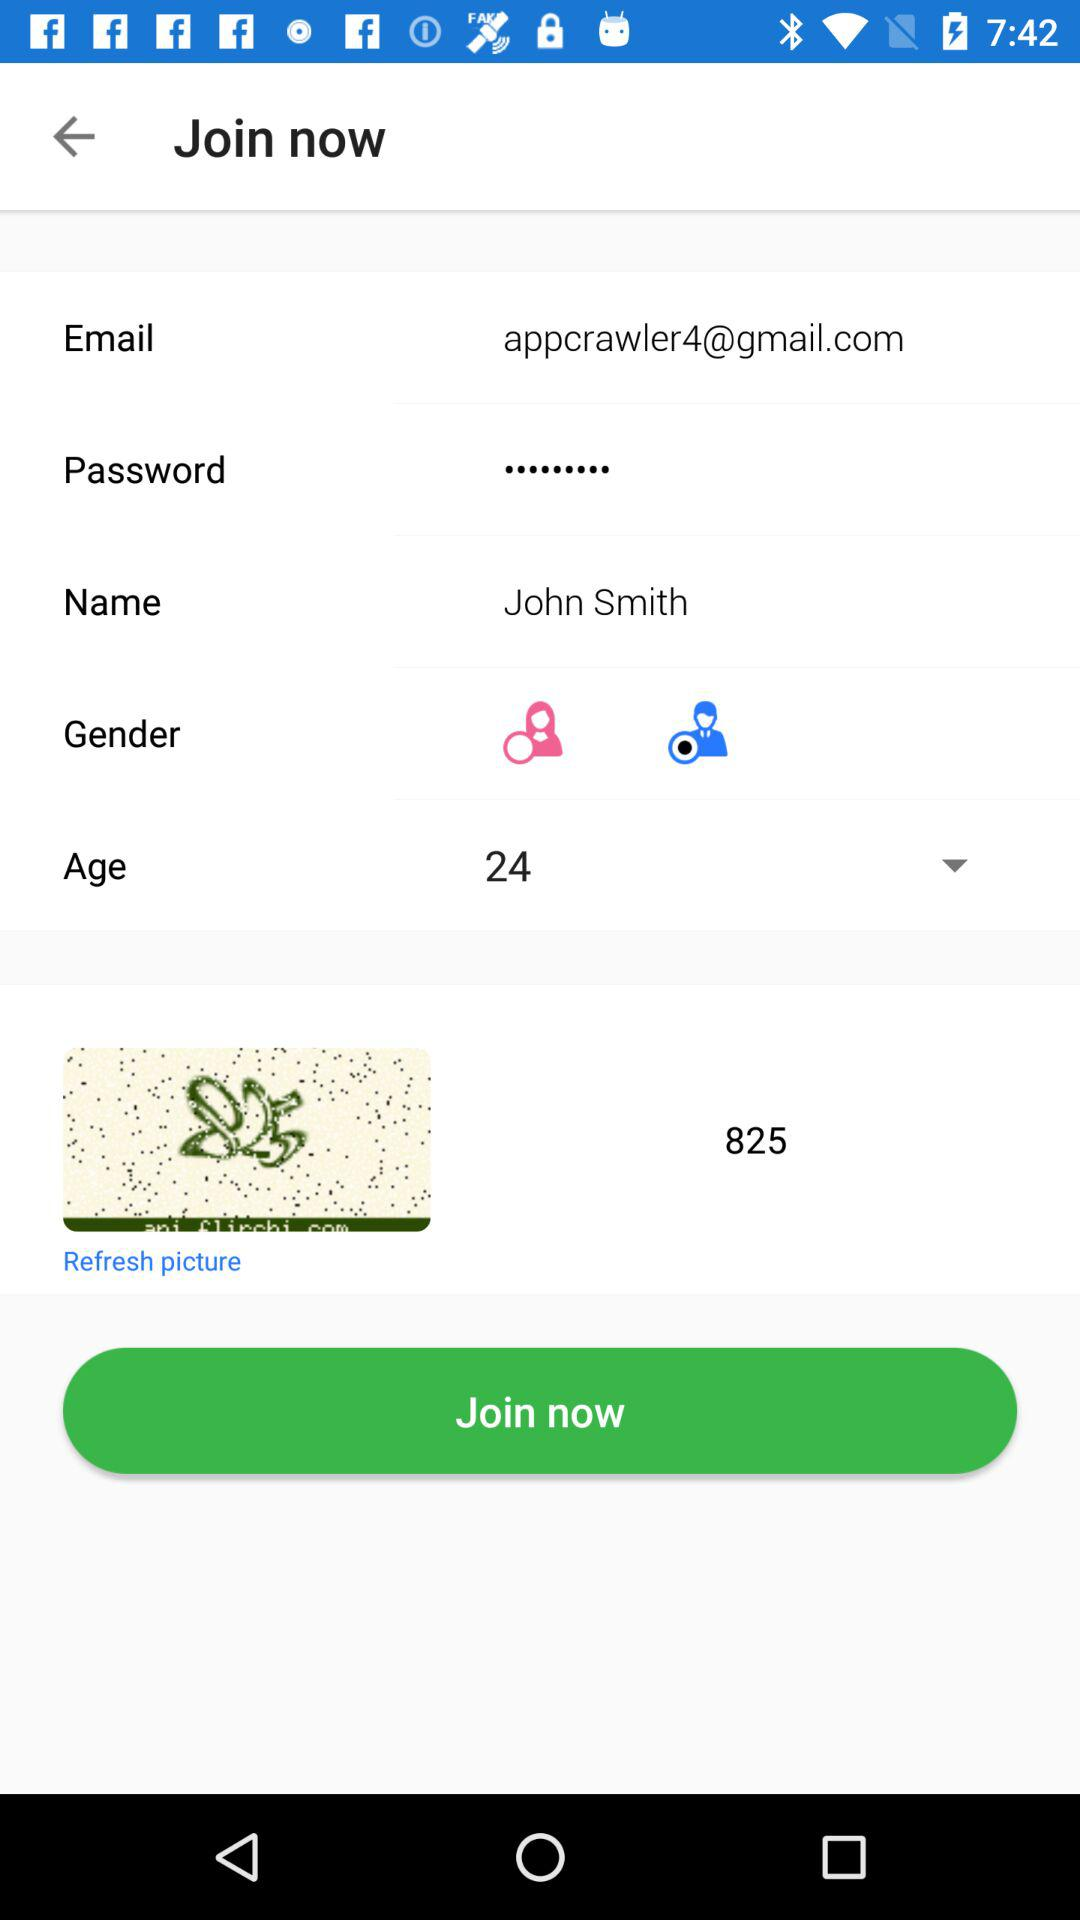What is the email address? The email address is appcrawler4@gmail.com. 